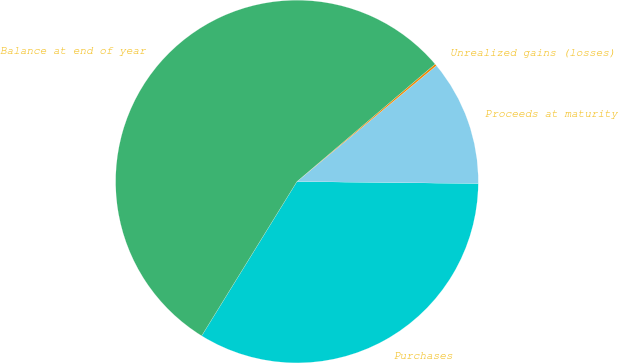Convert chart to OTSL. <chart><loc_0><loc_0><loc_500><loc_500><pie_chart><fcel>Purchases<fcel>Proceeds at maturity<fcel>Unrealized gains (losses)<fcel>Balance at end of year<nl><fcel>33.63%<fcel>11.21%<fcel>0.18%<fcel>54.97%<nl></chart> 